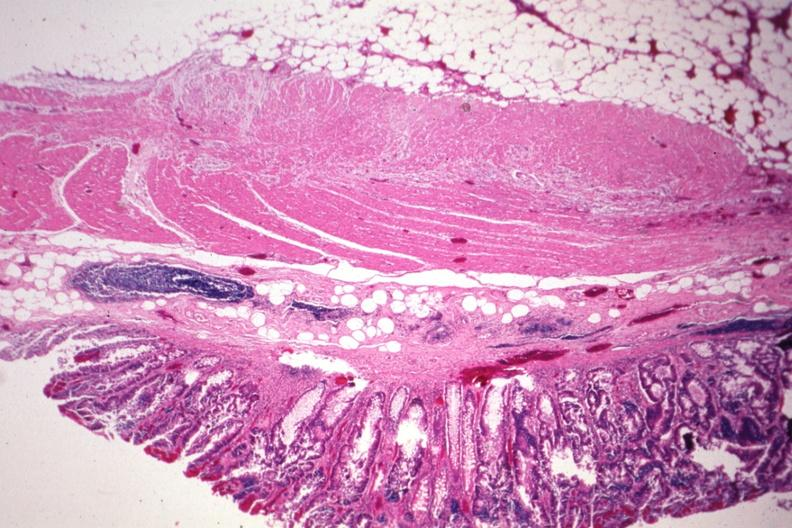does situs inversus show nice photo with obvious tumor in mucosa?
Answer the question using a single word or phrase. No 